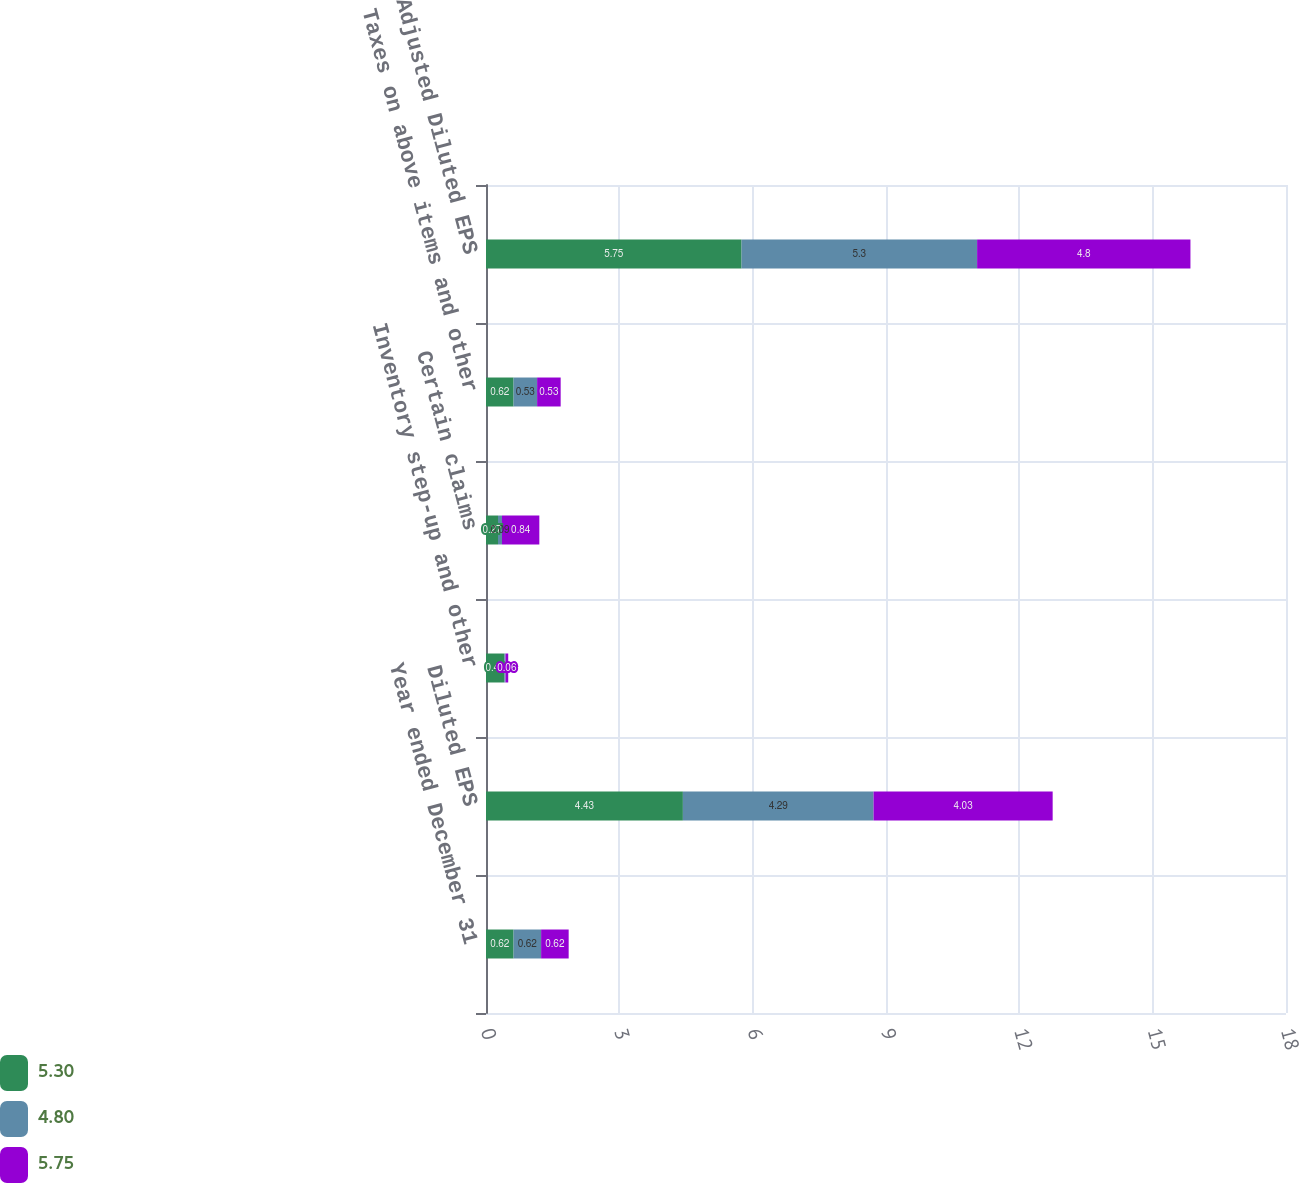Convert chart. <chart><loc_0><loc_0><loc_500><loc_500><stacked_bar_chart><ecel><fcel>Year ended December 31<fcel>Diluted EPS<fcel>Inventory step-up and other<fcel>Certain claims<fcel>Taxes on above items and other<fcel>Adjusted Diluted EPS<nl><fcel>5.3<fcel>0.62<fcel>4.43<fcel>0.41<fcel>0.27<fcel>0.62<fcel>5.75<nl><fcel>4.8<fcel>0.62<fcel>4.29<fcel>0.03<fcel>0.09<fcel>0.53<fcel>5.3<nl><fcel>5.75<fcel>0.62<fcel>4.03<fcel>0.06<fcel>0.84<fcel>0.53<fcel>4.8<nl></chart> 